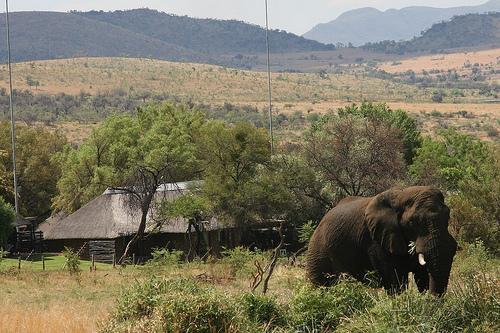How many elephants are visible in the photo?
Give a very brief answer. 1. 